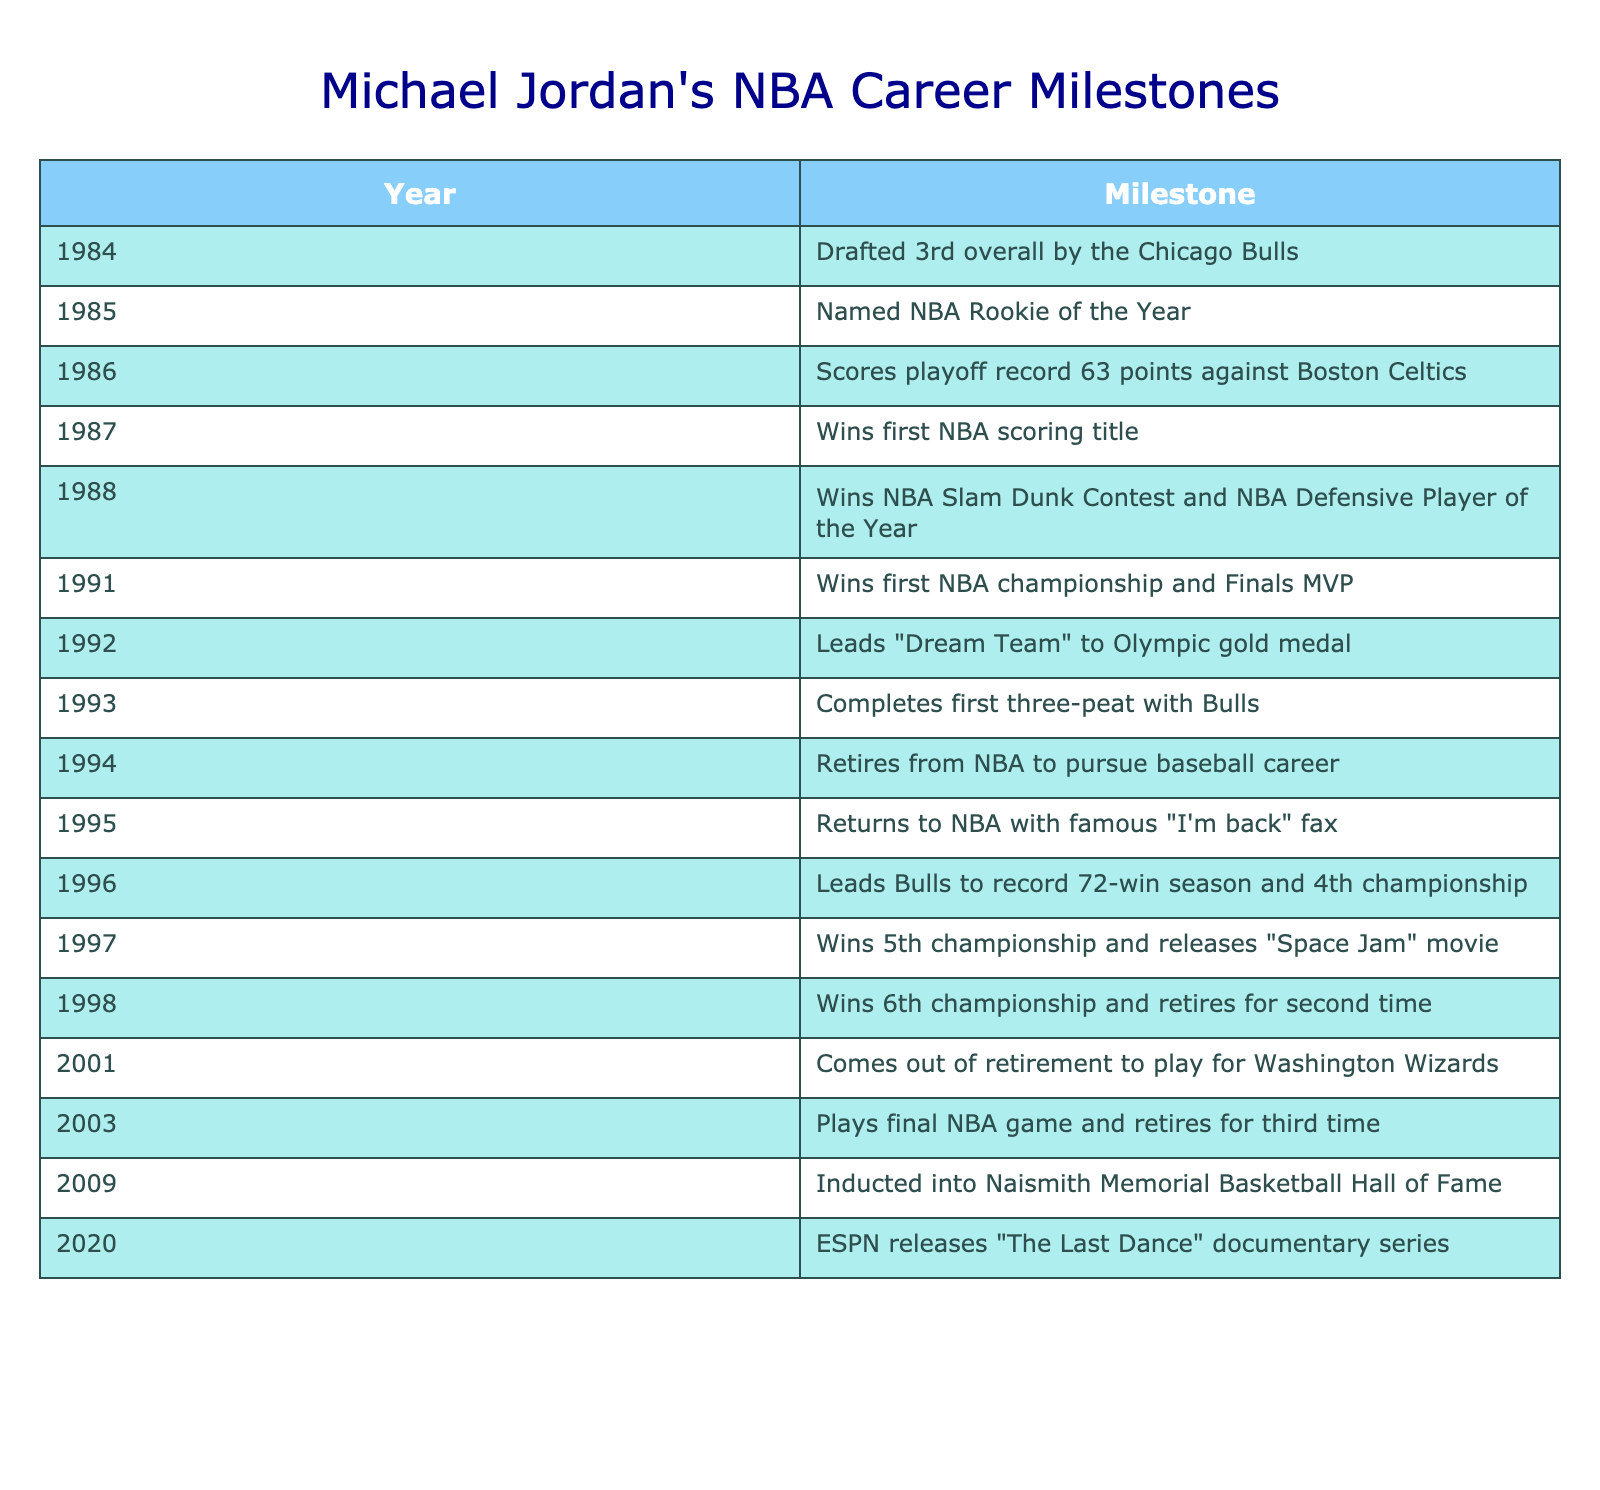What year was Michael Jordan drafted? The table indicates that Michael Jordan was drafted 3rd overall by the Chicago Bulls in 1984.
Answer: 1984 How many NBA championships did Michael Jordan win? Referring to the table, the milestones show that he won a total of 6 championships (1991, 1992, 1993, 1996, 1997, 1998).
Answer: 6 What milestone did Michael Jordan achieve in 1988? The table states that in 1988, Michael Jordan won both the NBA Slam Dunk Contest and the NBA Defensive Player of the Year award.
Answer: Won Slam Dunk Contest and Defensive Player of the Year In what year did Jordan first retire from the NBA? The table clearly notes that Michael Jordan retired from the NBA for the first time in 1994.
Answer: 1994 Which milestone marks the completion of Jordan's first three-peat? The table shows that Michael Jordan completed his first three-peat with the Bulls in 1993.
Answer: Completed first three-peat in 1993 How many years did Michael Jordan play in the NBA from his debut until his final retirement? To determine this, calculate the years between his draft in 1984 and his last retirement in 2003. That gives us 2003 - 1984 = 19 years.
Answer: 19 years Did Michael Jordan ever return to play after his initial retirement? Yes, the table indicates that he returned to the NBA in 1995 after his first retirement in 1994.
Answer: Yes What significant event occurred for Michael Jordan in 2009? According to the table, in 2009, Michael Jordan was inducted into the Naismith Memorial Basketball Hall of Fame.
Answer: Inducted into Hall of Fame In which year did Jordan release the movie "Space Jam"? The table specifies that Michael Jordan released "Space Jam" in 1997.
Answer: 1997 What percentage of championships did Michael Jordan win in the 1990s based on the milestones? Jordan won 5 championships from 1991 to 1998, which are within the 1990s, out of the total 6 championships he won. This gives us (5/6) * 100 = approximately 83.33%.
Answer: 83.33% 